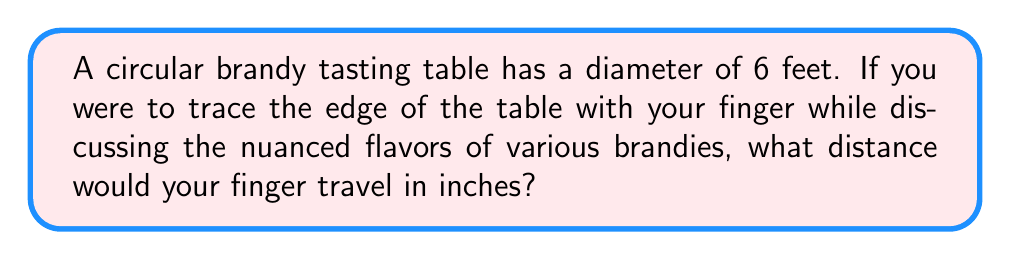What is the answer to this math problem? Let's approach this step-by-step:

1) First, recall the formula for the circumference of a circle:
   $$C = \pi d$$
   where $C$ is the circumference and $d$ is the diameter.

2) We're given the diameter: $d = 6$ feet.

3) Let's substitute this into our formula:
   $$C = \pi \cdot 6$$

4) We can simplify this:
   $$C = 6\pi \text{ feet}$$

5) Now, we need to convert this to inches. There are 12 inches in a foot, so we multiply by 12:
   $$C = 6\pi \cdot 12 \text{ inches}$$

6) Simplifying:
   $$C = 72\pi \text{ inches}$$

7) If we want to calculate this to a decimal approximation, we can use $\pi \approx 3.14159$:
   $$C \approx 72 \cdot 3.14159 \approx 226.19 \text{ inches}$$

Thus, your finger would travel approximately 226.19 inches around the edge of the brandy tasting table.
Answer: $72\pi$ inches or approximately 226.19 inches 